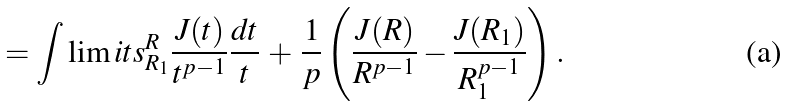<formula> <loc_0><loc_0><loc_500><loc_500>= \int \lim i t s _ { R _ { 1 } } ^ { R } \frac { J ( t ) } { t ^ { p - 1 } } \frac { d t } { t } \, + \, \frac { 1 } { p } \left ( \frac { J ( R ) } { R ^ { p - 1 } } - \frac { J ( R _ { 1 } ) } { R _ { 1 } ^ { p - 1 } } \right ) .</formula> 